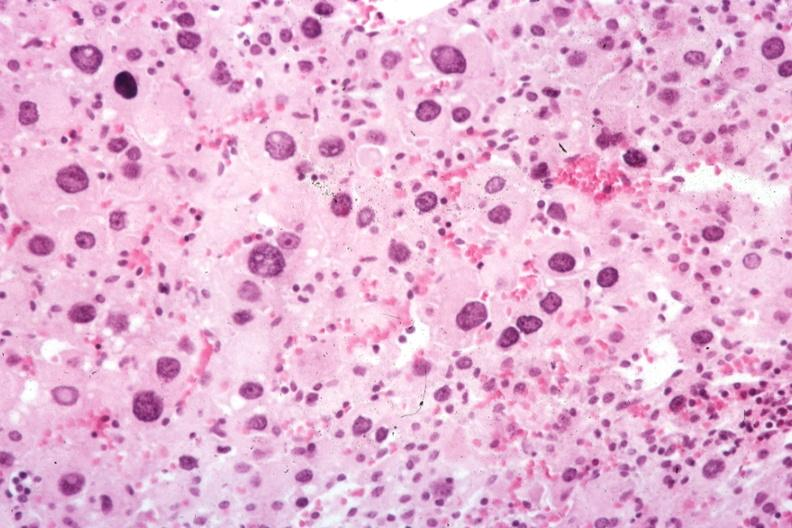what does this image show?
Answer the question using a single word or phrase. Typical cells 